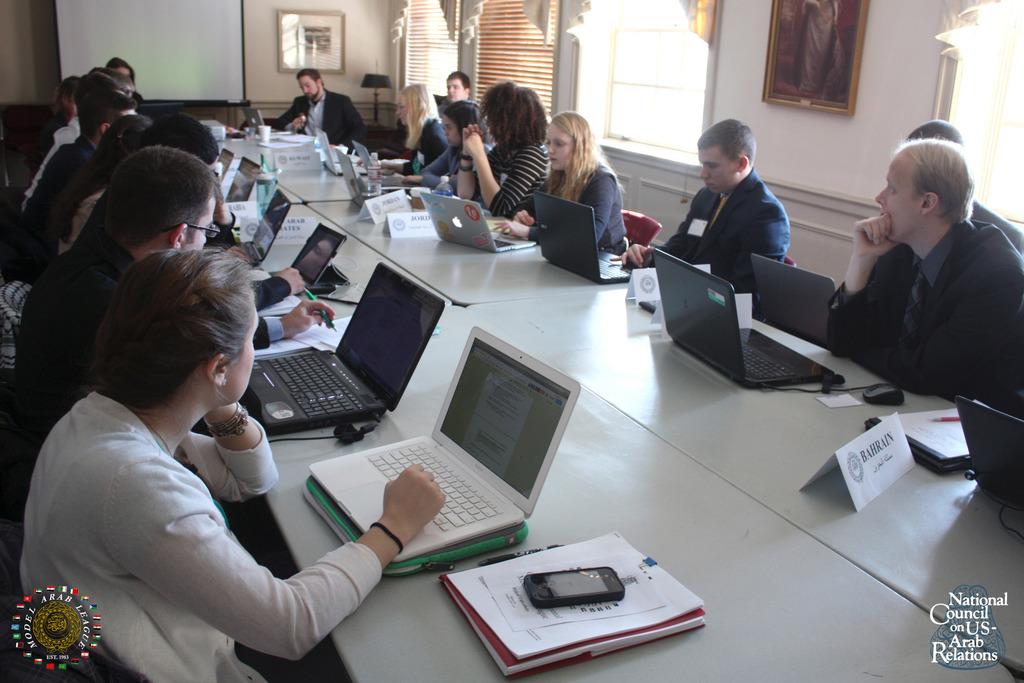What country is shown on the lower right corner placard?
Keep it short and to the point. Bahrain. What type of council is this?
Provide a short and direct response. National council on us-arab relations. 